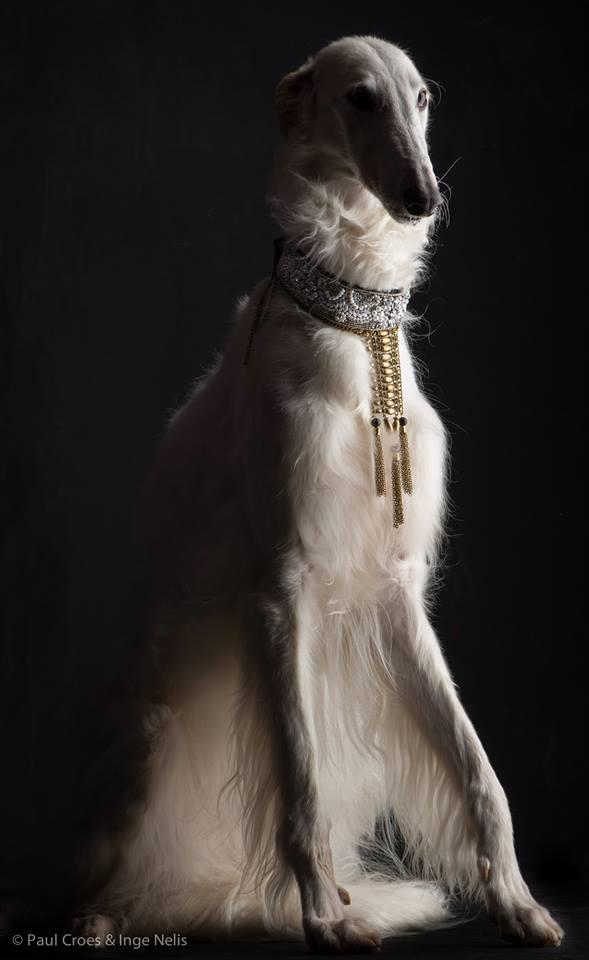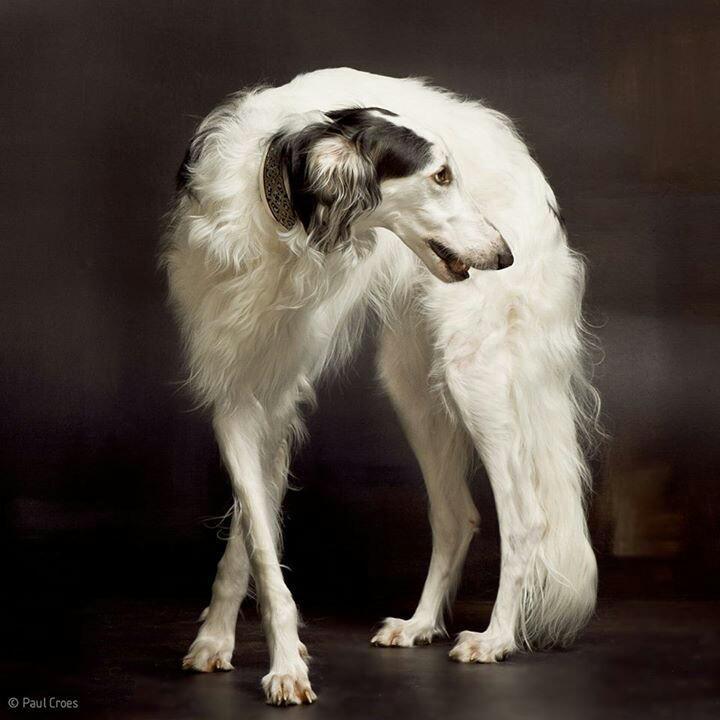The first image is the image on the left, the second image is the image on the right. Examine the images to the left and right. Is the description "The right image shows a hound posed on an upholstered chair, with one front paw propped on the side of the chair." accurate? Answer yes or no. No. The first image is the image on the left, the second image is the image on the right. For the images shown, is this caption "A dog is in a chair." true? Answer yes or no. No. 